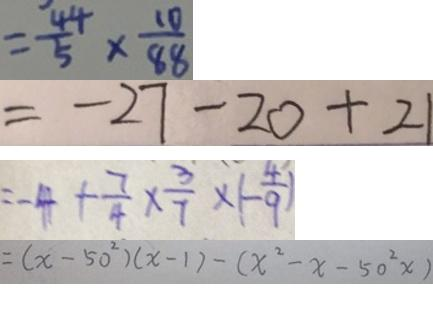Convert formula to latex. <formula><loc_0><loc_0><loc_500><loc_500>= \frac { 4 4 } { 5 } \times \frac { 1 0 } { 8 8 } 
 = - 2 7 - 2 0 + 2 1 
 = - 4 + \frac { 7 } { 4 } \times \frac { 3 } { 7 } \times ( - \frac { 4 } { 9 } ) 
 = ( x - 5 0 ^ { 2 } ) ( x - 1 ) - ( x ^ { 2 } - x - 5 0 ^ { 2 } )</formula> 